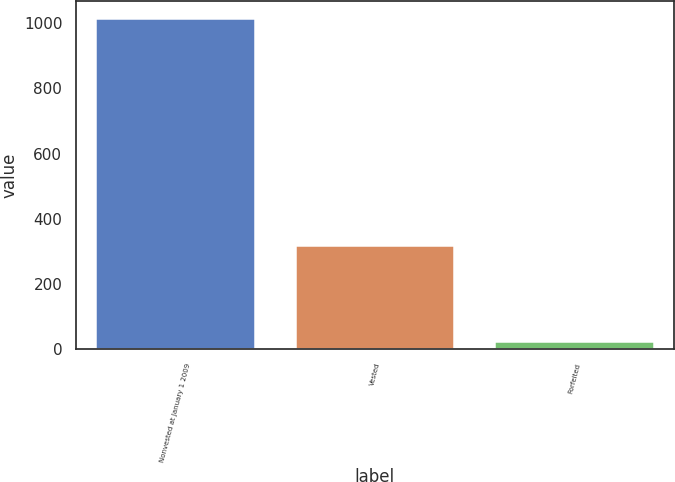<chart> <loc_0><loc_0><loc_500><loc_500><bar_chart><fcel>Nonvested at January 1 2009<fcel>Vested<fcel>Forfeited<nl><fcel>1017<fcel>321<fcel>26<nl></chart> 